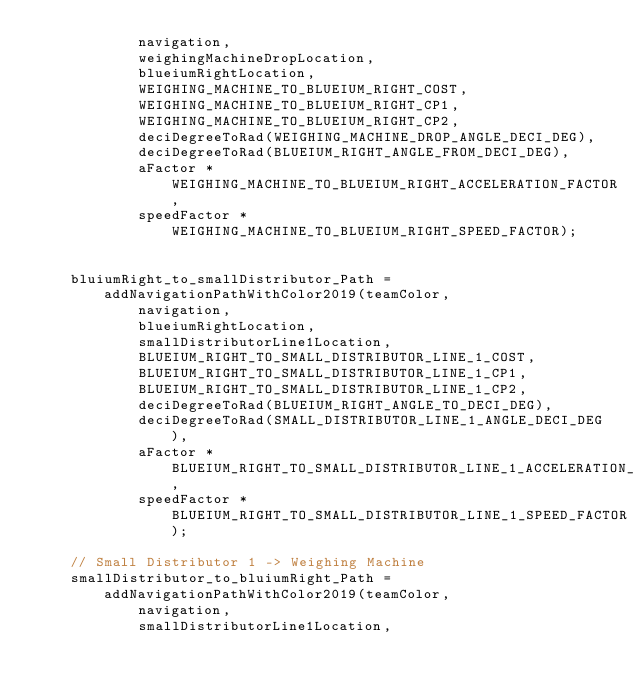<code> <loc_0><loc_0><loc_500><loc_500><_C_>            navigation,
            weighingMachineDropLocation,
            blueiumRightLocation,
            WEIGHING_MACHINE_TO_BLUEIUM_RIGHT_COST,
            WEIGHING_MACHINE_TO_BLUEIUM_RIGHT_CP1,
            WEIGHING_MACHINE_TO_BLUEIUM_RIGHT_CP2,
            deciDegreeToRad(WEIGHING_MACHINE_DROP_ANGLE_DECI_DEG),
            deciDegreeToRad(BLUEIUM_RIGHT_ANGLE_FROM_DECI_DEG),
            aFactor * WEIGHING_MACHINE_TO_BLUEIUM_RIGHT_ACCELERATION_FACTOR,
            speedFactor * WEIGHING_MACHINE_TO_BLUEIUM_RIGHT_SPEED_FACTOR);


    bluiumRight_to_smallDistributor_Path = addNavigationPathWithColor2019(teamColor,
            navigation,
            blueiumRightLocation,
            smallDistributorLine1Location,
            BLUEIUM_RIGHT_TO_SMALL_DISTRIBUTOR_LINE_1_COST,
            BLUEIUM_RIGHT_TO_SMALL_DISTRIBUTOR_LINE_1_CP1,
            BLUEIUM_RIGHT_TO_SMALL_DISTRIBUTOR_LINE_1_CP2,
            deciDegreeToRad(BLUEIUM_RIGHT_ANGLE_TO_DECI_DEG),
            deciDegreeToRad(SMALL_DISTRIBUTOR_LINE_1_ANGLE_DECI_DEG),
            aFactor * BLUEIUM_RIGHT_TO_SMALL_DISTRIBUTOR_LINE_1_ACCELERATION_FACTOR,
            speedFactor * BLUEIUM_RIGHT_TO_SMALL_DISTRIBUTOR_LINE_1_SPEED_FACTOR);

    // Small Distributor 1 -> Weighing Machine
    smallDistributor_to_bluiumRight_Path = addNavigationPathWithColor2019(teamColor,
            navigation,
            smallDistributorLine1Location,</code> 